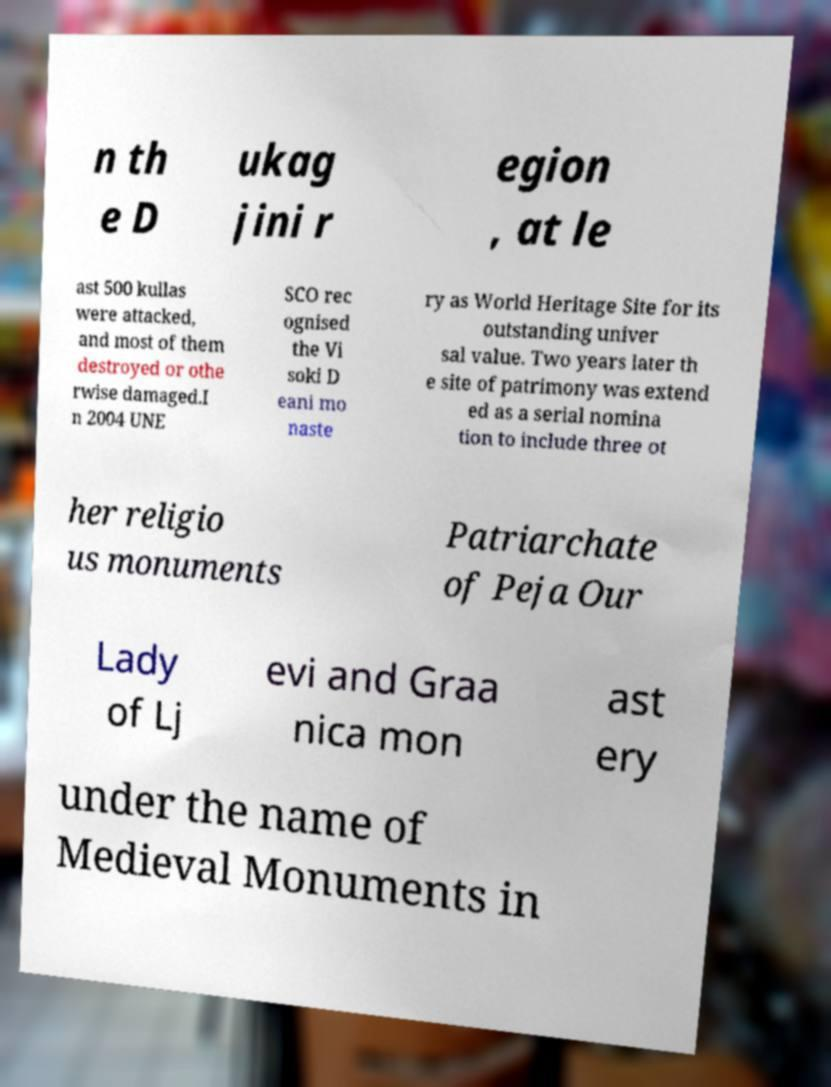Can you read and provide the text displayed in the image?This photo seems to have some interesting text. Can you extract and type it out for me? n th e D ukag jini r egion , at le ast 500 kullas were attacked, and most of them destroyed or othe rwise damaged.I n 2004 UNE SCO rec ognised the Vi soki D eani mo naste ry as World Heritage Site for its outstanding univer sal value. Two years later th e site of patrimony was extend ed as a serial nomina tion to include three ot her religio us monuments Patriarchate of Peja Our Lady of Lj evi and Graa nica mon ast ery under the name of Medieval Monuments in 